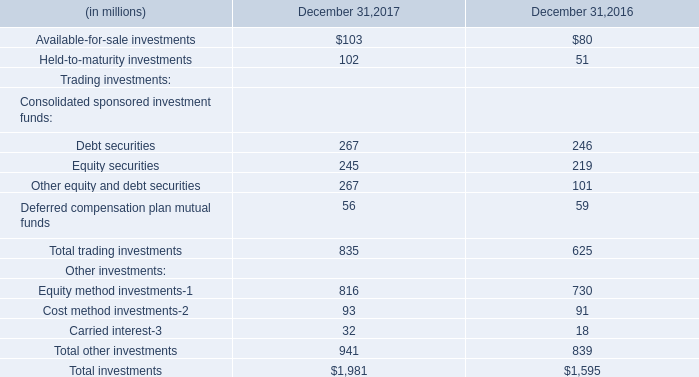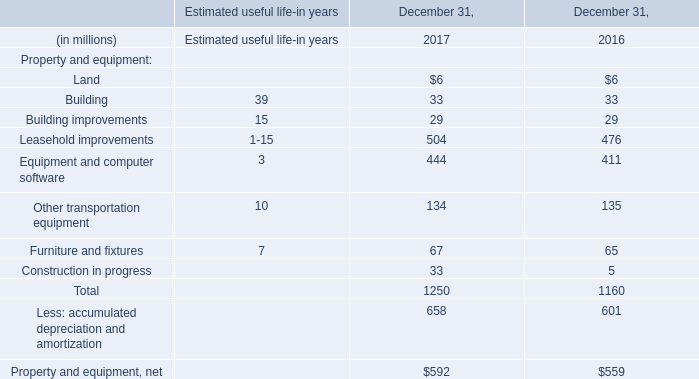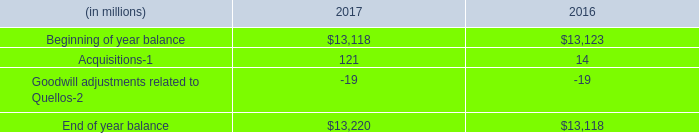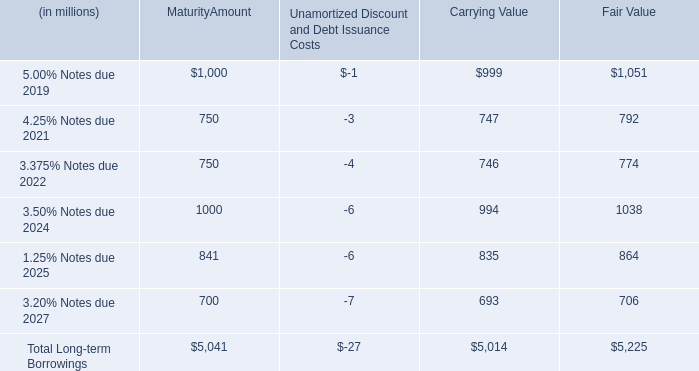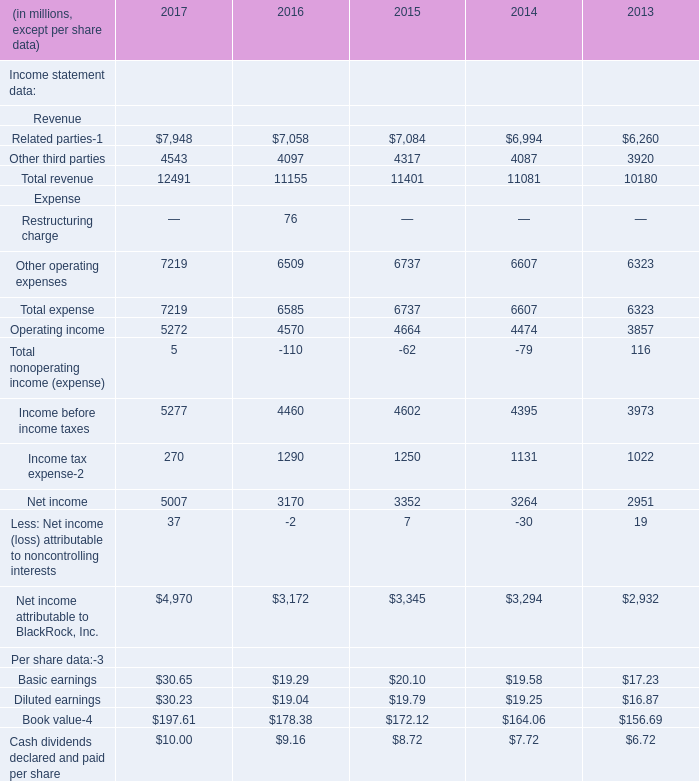What's the total amount of Related parties, Other third parties, Total revenue and Other operating expenses in 2017? (in million) 
Computations: (((7948 + 4543) + 12491) + 7219)
Answer: 32201.0. 